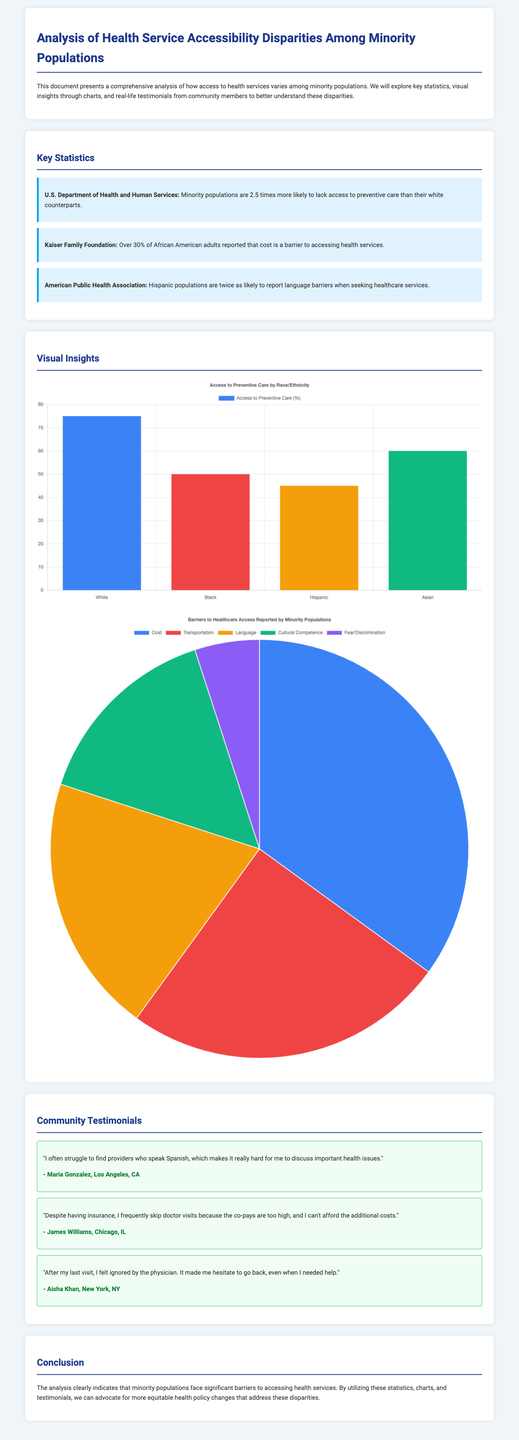What percentage of Black individuals access preventive care? The chart indicates that 50% of Black individuals have access to preventive care, which is illustrated numerically in the data provided.
Answer: 50% What is the main barrier reported by minority populations in accessing healthcare? According to the barriers chart, the largest segment is labeled as "Cost," which accounts for 35% of the reported barriers.
Answer: Cost How many community testimonials are included in the document? The document includes a section dedicated to community testimonials, which consists of three testimonials provided by community members.
Answer: 3 What percentage of Hispanic populations report language barriers when seeking healthcare? The statistic states that Hispanic populations are twice as likely to report language barriers, indicating a significant issue in healthcare access related to language differences.
Answer: Twice What does the Preventive Care Chart compare? The Preventive Care Chart compares access to preventive care among different racial and ethnic groups. The labels indicate these distinct groups.
Answer: Racial and ethnic groups What was the reported percentage of African American adults who cited cost as a barrier? The statistic from the Kaiser Family Foundation specifies that over 30% of African American adults noted that cost is a barrier to health service access.
Answer: Over 30% What color represents "Transportation" in the Barriers Chart? The Barriers Chart utilizes a specific color to represent each category, with "Transportation" associated with the color red from the chart's color coding.
Answer: Red What is the title of the document? The title of the document, prominently displayed at the top, sets the context for the analysis presented within, focusing on health service accessibility.
Answer: Analysis of Health Service Accessibility Disparities Among Minority Populations 